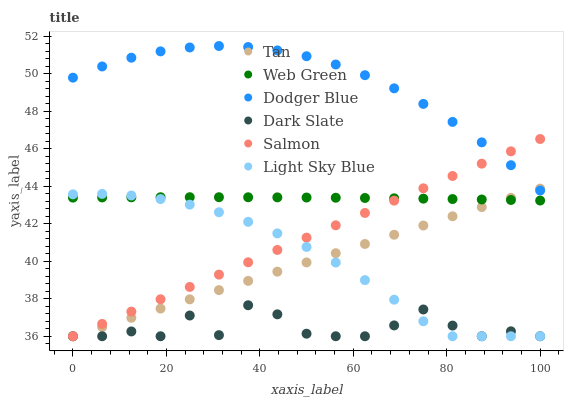Does Dark Slate have the minimum area under the curve?
Answer yes or no. Yes. Does Dodger Blue have the maximum area under the curve?
Answer yes or no. Yes. Does Web Green have the minimum area under the curve?
Answer yes or no. No. Does Web Green have the maximum area under the curve?
Answer yes or no. No. Is Salmon the smoothest?
Answer yes or no. Yes. Is Dark Slate the roughest?
Answer yes or no. Yes. Is Web Green the smoothest?
Answer yes or no. No. Is Web Green the roughest?
Answer yes or no. No. Does Salmon have the lowest value?
Answer yes or no. Yes. Does Web Green have the lowest value?
Answer yes or no. No. Does Dodger Blue have the highest value?
Answer yes or no. Yes. Does Web Green have the highest value?
Answer yes or no. No. Is Dark Slate less than Web Green?
Answer yes or no. Yes. Is Dodger Blue greater than Dark Slate?
Answer yes or no. Yes. Does Salmon intersect Web Green?
Answer yes or no. Yes. Is Salmon less than Web Green?
Answer yes or no. No. Is Salmon greater than Web Green?
Answer yes or no. No. Does Dark Slate intersect Web Green?
Answer yes or no. No. 